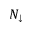Convert formula to latex. <formula><loc_0><loc_0><loc_500><loc_500>N _ { \downarrow }</formula> 